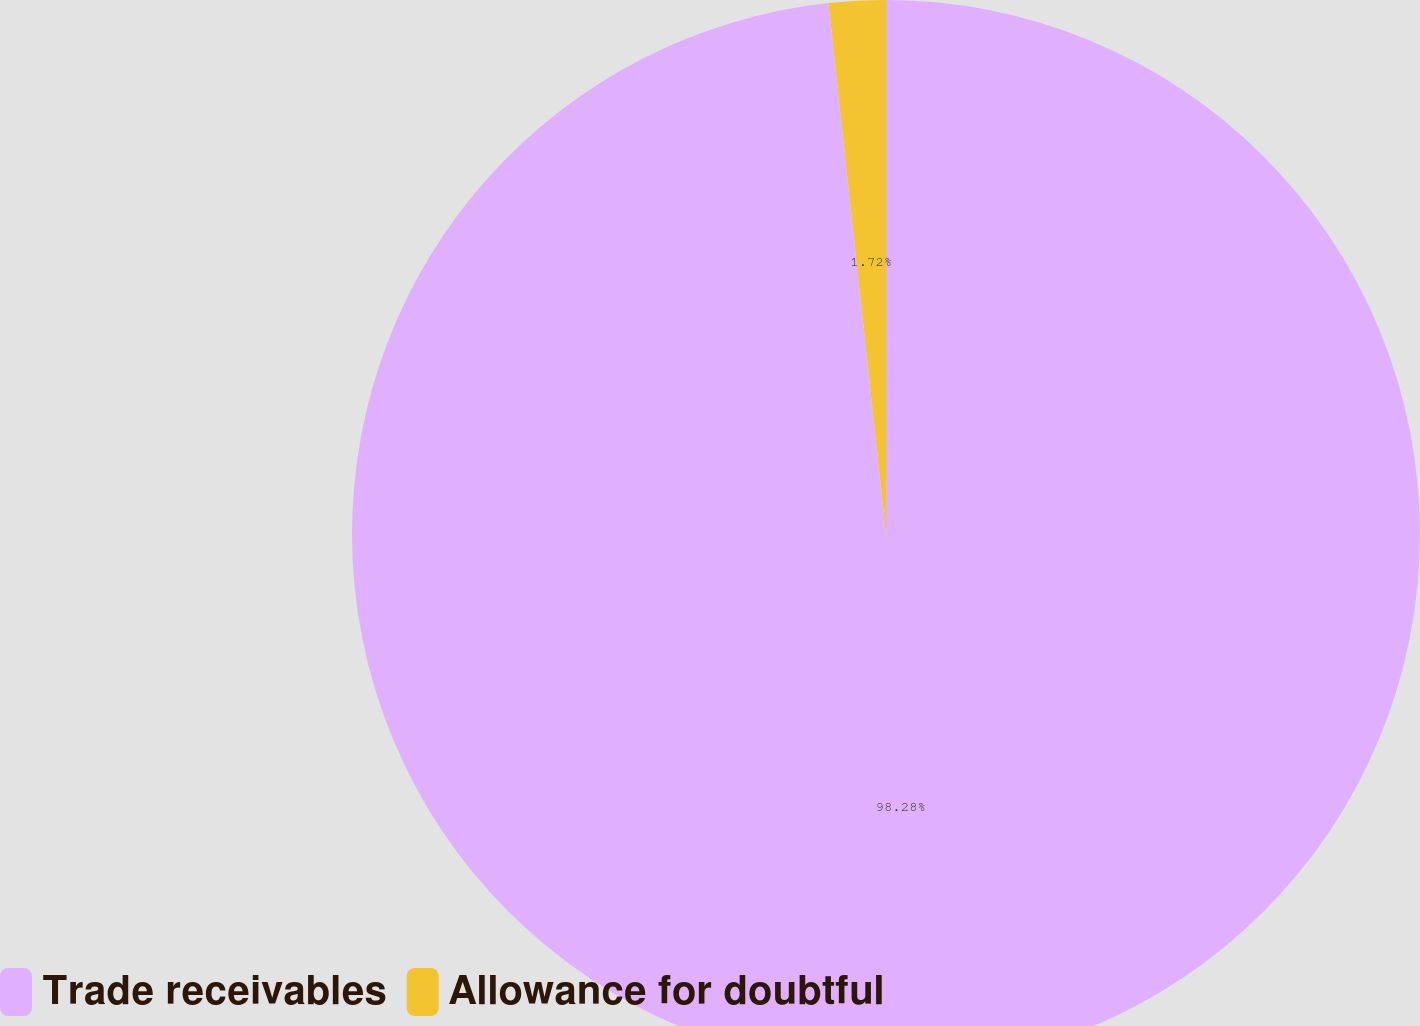<chart> <loc_0><loc_0><loc_500><loc_500><pie_chart><fcel>Trade receivables<fcel>Allowance for doubtful<nl><fcel>98.28%<fcel>1.72%<nl></chart> 